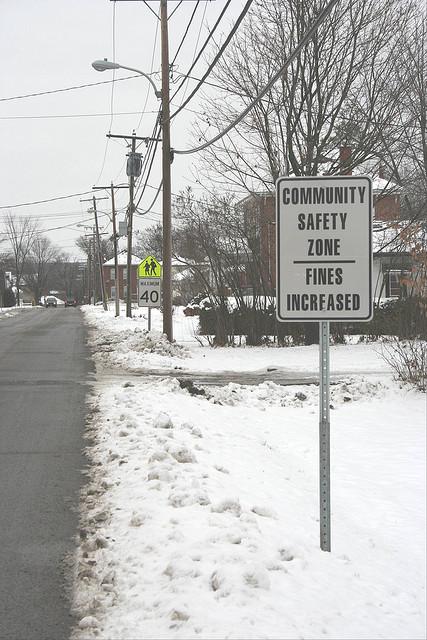Is this a safety zone?
Keep it brief. Yes. What is on the ground?
Write a very short answer. Snow. What is the speed limit in this area?
Write a very short answer. 40. What does the sign say?
Write a very short answer. Community safety zone. What does the numbers on the floor represent?
Give a very brief answer. Speed limit. 